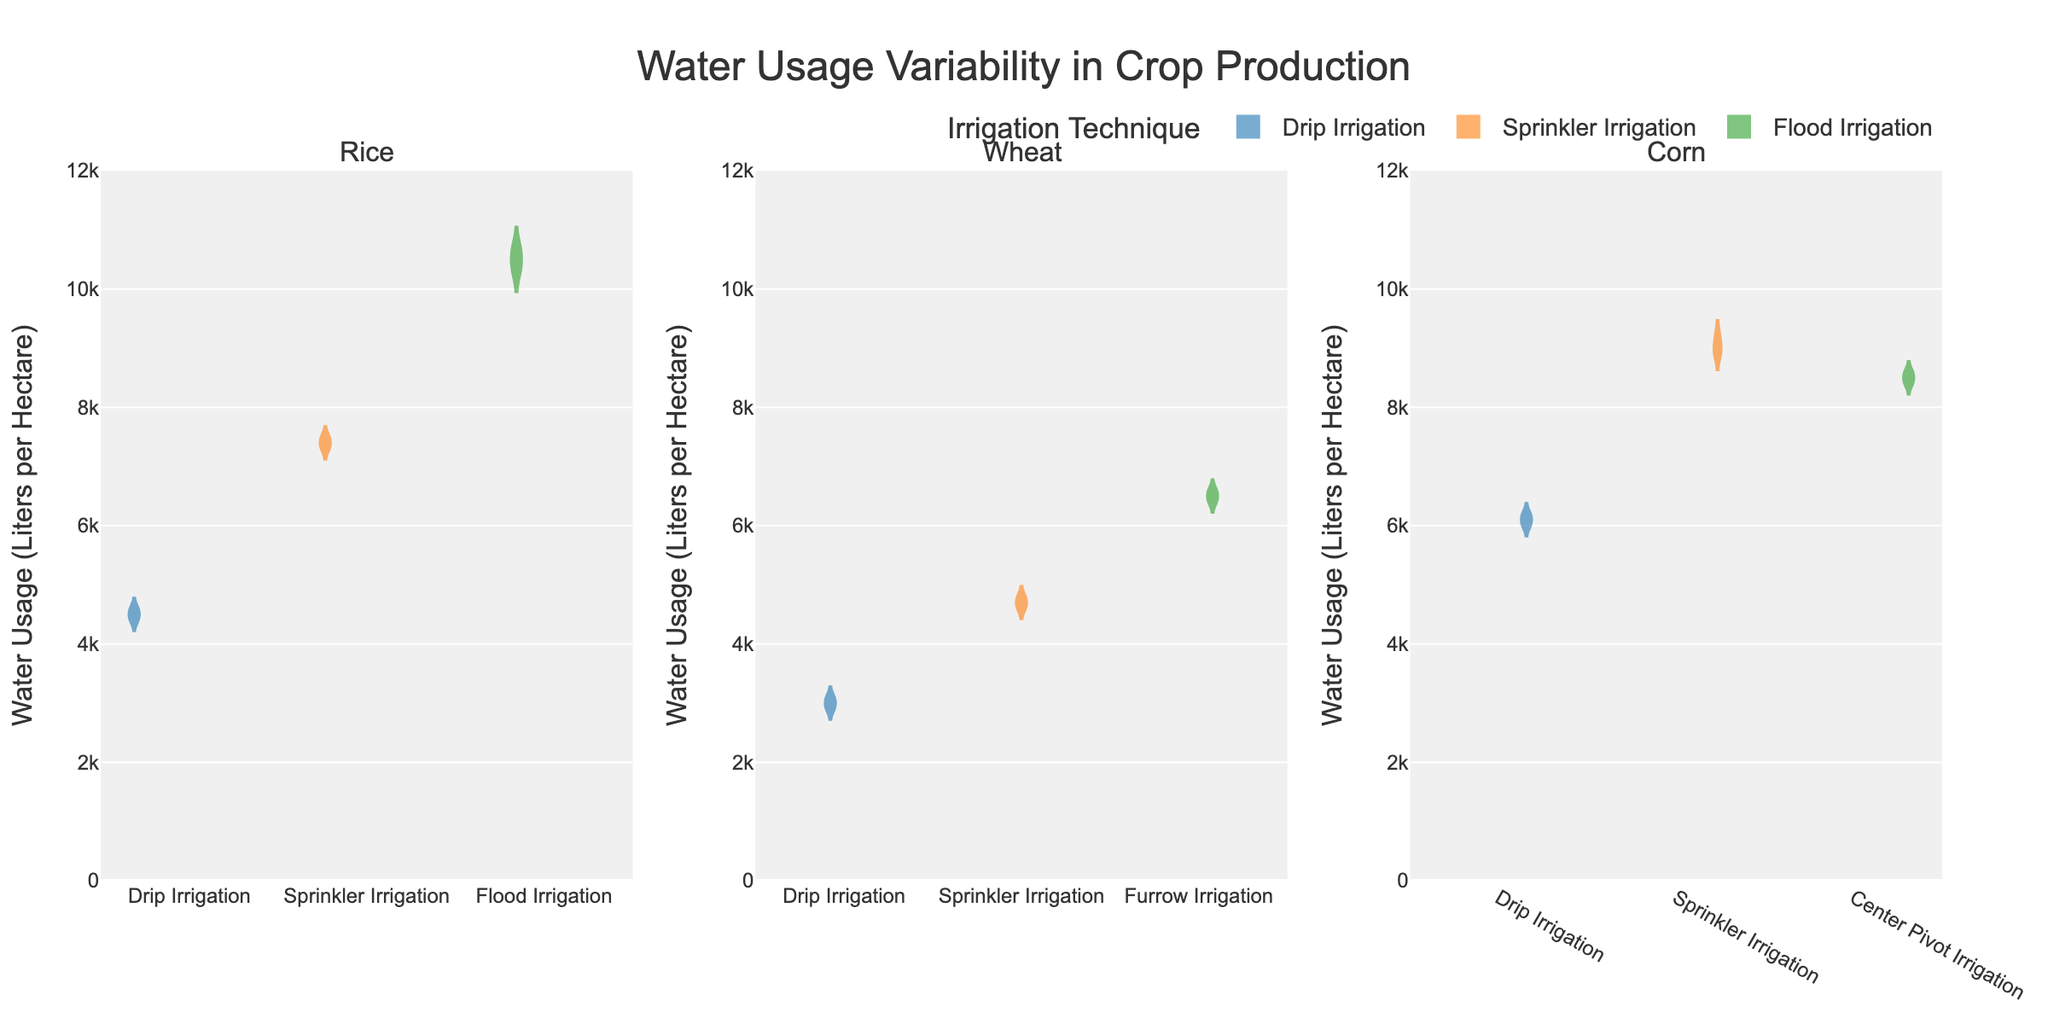What is the title of the figure? The title of the figure is located at the top, centered above the plot. It’s written in a larger font size and reads: "Water Usage Variability in Crop Production". This title summarizes the main topic of the figure.
Answer: Water Usage Variability in Crop Production What are the axes titles? The Y-axis title is present on the left-hand side of the plot and it reads "Water Usage (Liters per Hectare)". The X-axis doesn't have a title but it categorizes the plot into three subplots: Rice, Wheat, and Corn.
Answer: Water Usage (Liters per Hectare) Which irrigation technique shows the highest water usage for Rice? Look for the highest point in the violin plots under the Rice category. The Flood Irrigation plot extends the highest compared to Drip and Sprinkler Irrigations.
Answer: Flood Irrigation Which irrigation technique for Wheat shows the smallest variability in water usage? To determine variability, inspect the spread of the violin plots for Wheat. The Drip Irrigation plot is the narrowest with the least spread, indicating the smallest variability.
Answer: Drip Irrigation Among all irrigation techniques shown, which one results in the highest water usage and for which crop? Compare the maximum points of all the violin plots. Flood Irrigation for Rice has the highest maximum water usage among all techniques and crops.
Answer: Flood Irrigation for Rice Which irrigation technique for Corn appears to be the most efficient in terms of water usage? Efficiency here implies lower water usage. For Corn, Drip Irrigation has the lowest points in terms of water usage when compared to Sprinkler and Center Pivot Irrigation.
Answer: Drip Irrigation What is the approximate median water usage for Wheat with Furrow Irrigation? The median value for each violin plot is marked by a meanline in the center. In the plot for Wheat with Furrow Irrigation, the median line is approximately at 6500 liters per hectare.
Answer: 6500 liters per hectare How does the water usage for Sprinkler Irrigation compare between Rice and Corn? Compare the median lines and ranges of the Sprinkler Irrigation violins for Rice and Corn. Rice has a higher median and a wider range than Corn.
Answer: Higher for Rice Can you rank the crops (Rice, Wheat, Corn) based on average water usage for Drip Irrigation from highest to lowest? Compare the average water usage lines for Drip Irrigation in each crop’s subplot. Rice has the highest average, followed by Corn, and then Wheat.
Answer: Rice, Corn, Wheat What general trend can be observed from the plots regarding water usage across different irrigation techniques? Examine all the violin plots to identify any patterns. Generally, Flood and Furrow Irrigation techniques show higher water usage and variability, whereas Drip Irrigation is consistently lower in water usage across all crops.
Answer: Higher water usage for Flood/Furrow, lower for Drip 